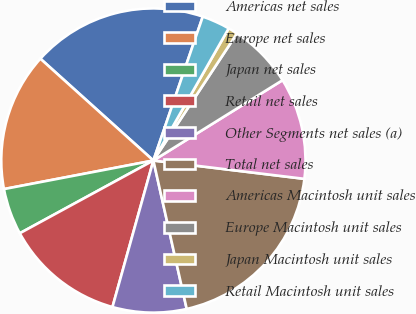Convert chart. <chart><loc_0><loc_0><loc_500><loc_500><pie_chart><fcel>Americas net sales<fcel>Europe net sales<fcel>Japan net sales<fcel>Retail net sales<fcel>Other Segments net sales (a)<fcel>Total net sales<fcel>Americas Macintosh unit sales<fcel>Europe Macintosh unit sales<fcel>Japan Macintosh unit sales<fcel>Retail Macintosh unit sales<nl><fcel>18.59%<fcel>14.68%<fcel>4.93%<fcel>12.73%<fcel>7.85%<fcel>19.56%<fcel>10.78%<fcel>6.88%<fcel>1.02%<fcel>2.98%<nl></chart> 